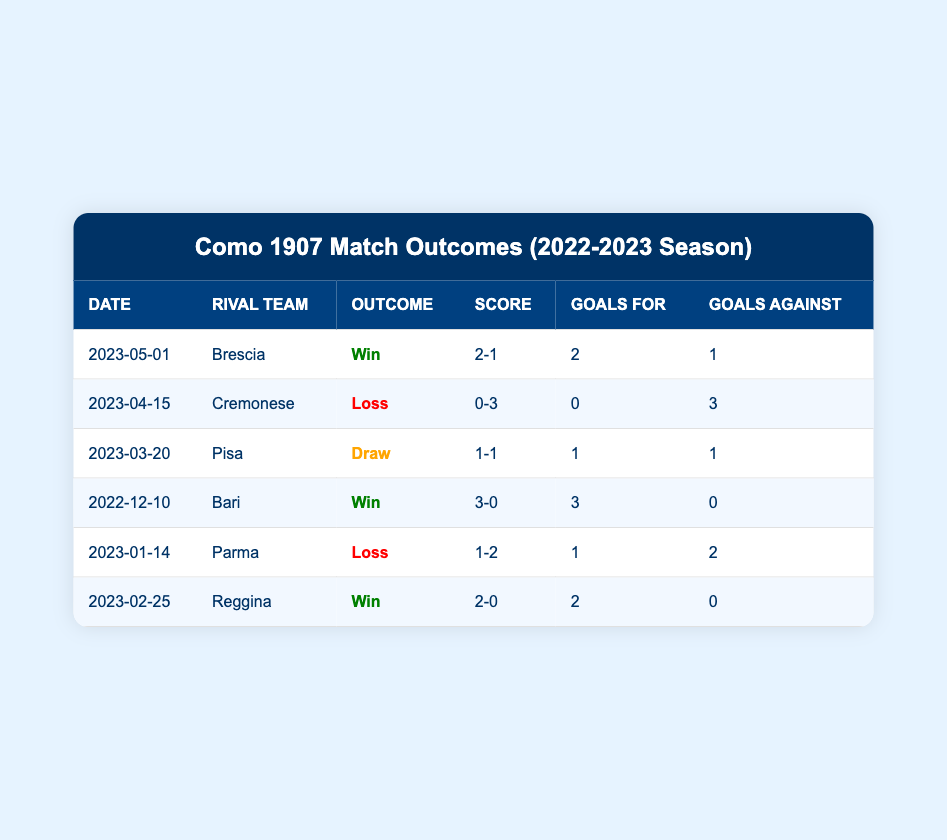What was the outcome of the match against Brescia? According to the table, the match against Brescia on 2023-05-01 had an outcome of "Win."
Answer: Win How many total goals did Como 1907 score in their matches against rival teams? To find the total goals scored by Como 1907, we add the goals for each match: 2 (Brescia) + 0 (Cremonese) + 1 (Pisa) + 3 (Bari) + 1 (Parma) + 2 (Reggina) = 9.
Answer: 9 Did Como 1907 draw any matches in the 2022-2023 season? The table shows that there is one match where Como 1907 drew, which was against Pisa on 2023-03-20.
Answer: Yes What was the score of the match with Reggina? From the table, the match with Reggina on 2023-02-25 ended with a score of 2-0.
Answer: 2-0 How many wins did Como 1907 achieve in the season? Como 1907 won against Brescia, Bari, and Reggina, totaling 3 wins.
Answer: 3 What was the goal difference in the match against Cremonese? In the match against Cremonese, Como 1907 scored 0 goals and conceded 3, giving a goal difference of 0 - 3 = -3.
Answer: -3 What percentage of Como 1907's matches ended in a win? Como 1907 played 6 matches: won 3, lost 2, and drew 1. To find the win percentage, we use the formula (number of wins/total matches) x 100 = (3/6) x 100 = 50%.
Answer: 50% Was there a match where Como 1907 scored more than two goals? The table indicates that Como 1907 scored more than two goals only in the match against Bari, where they scored 3 goals.
Answer: Yes In which match did Como 1907 receive the highest number of goals against? The match against Cremonese on 2023-04-15 resulted in the highest number of goals against Como 1907, with 3 goals conceded.
Answer: Cremonese 